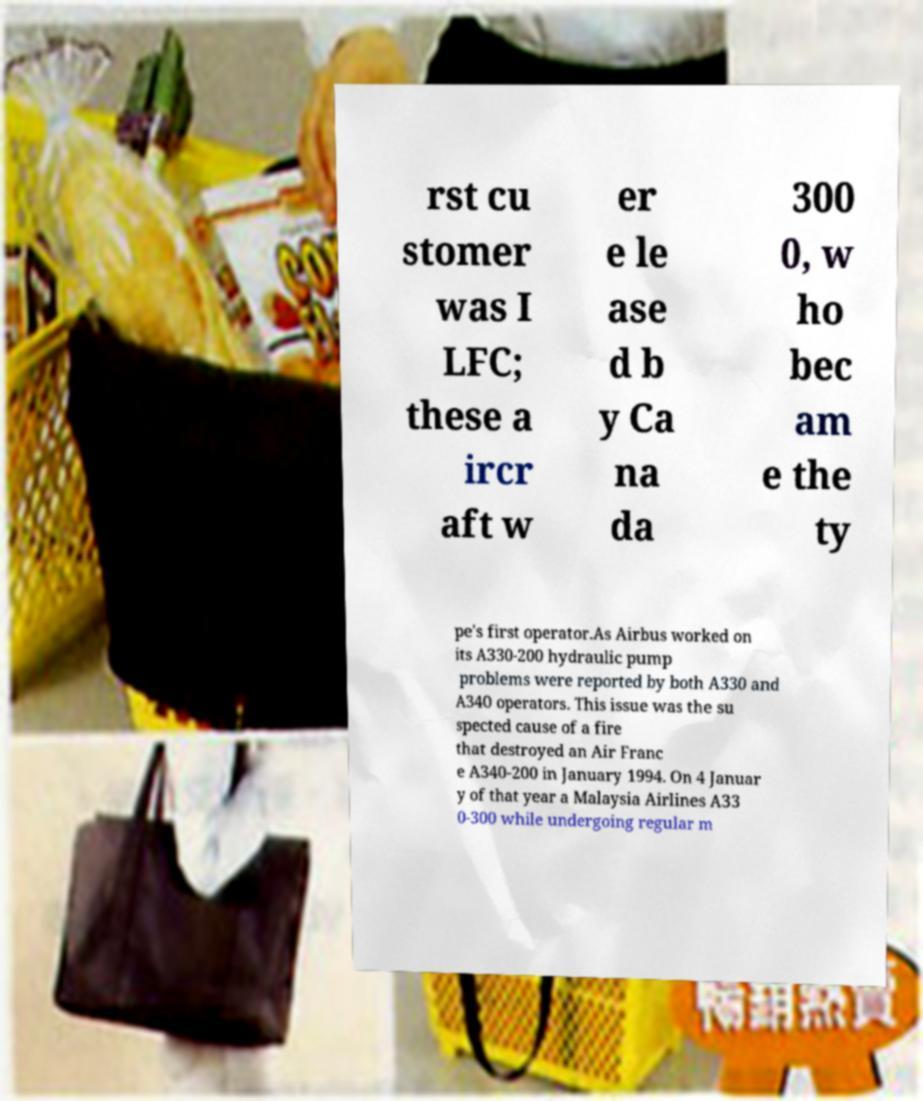Can you read and provide the text displayed in the image?This photo seems to have some interesting text. Can you extract and type it out for me? rst cu stomer was I LFC; these a ircr aft w er e le ase d b y Ca na da 300 0, w ho bec am e the ty pe's first operator.As Airbus worked on its A330-200 hydraulic pump problems were reported by both A330 and A340 operators. This issue was the su spected cause of a fire that destroyed an Air Franc e A340-200 in January 1994. On 4 Januar y of that year a Malaysia Airlines A33 0-300 while undergoing regular m 